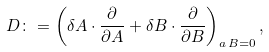<formula> <loc_0><loc_0><loc_500><loc_500>D \colon = \left ( \delta A \cdot \frac { \partial } { \partial A } + \delta B \cdot \frac { \partial } { \partial B } \right ) _ { a \, B = 0 } ,</formula> 